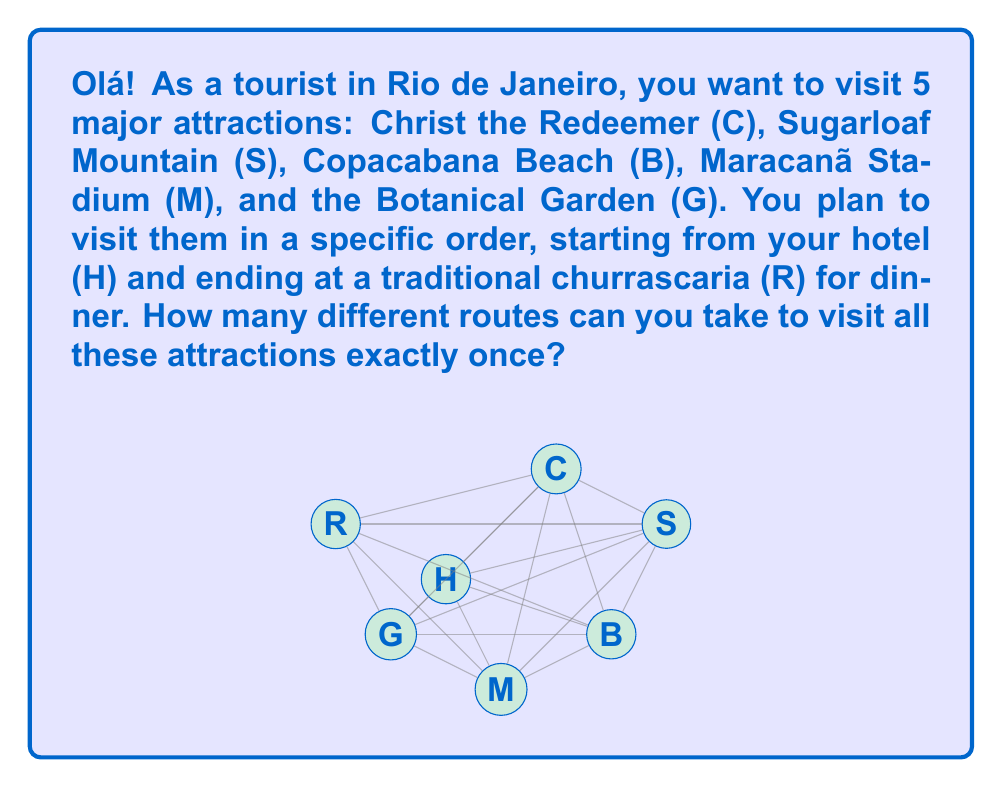What is the answer to this math problem? Let's approach this step-by-step:

1) We start at the hotel (H) and end at the restaurant (R), so these locations are fixed.

2) Between H and R, we need to arrange the 5 attractions in any order.

3) This is a permutation problem. We have 5 distinct attractions to arrange in order.

4) The number of permutations of n distinct objects is given by $n!$

5) In this case, $n = 5$, so we calculate $5!$:

   $$5! = 5 \times 4 \times 3 \times 2 \times 1 = 120$$

Therefore, there are 120 different ways to arrange the 5 attractions.

6) Each of these arrangements represents a unique route from H to R, visiting all attractions exactly once.
Answer: $120$ 